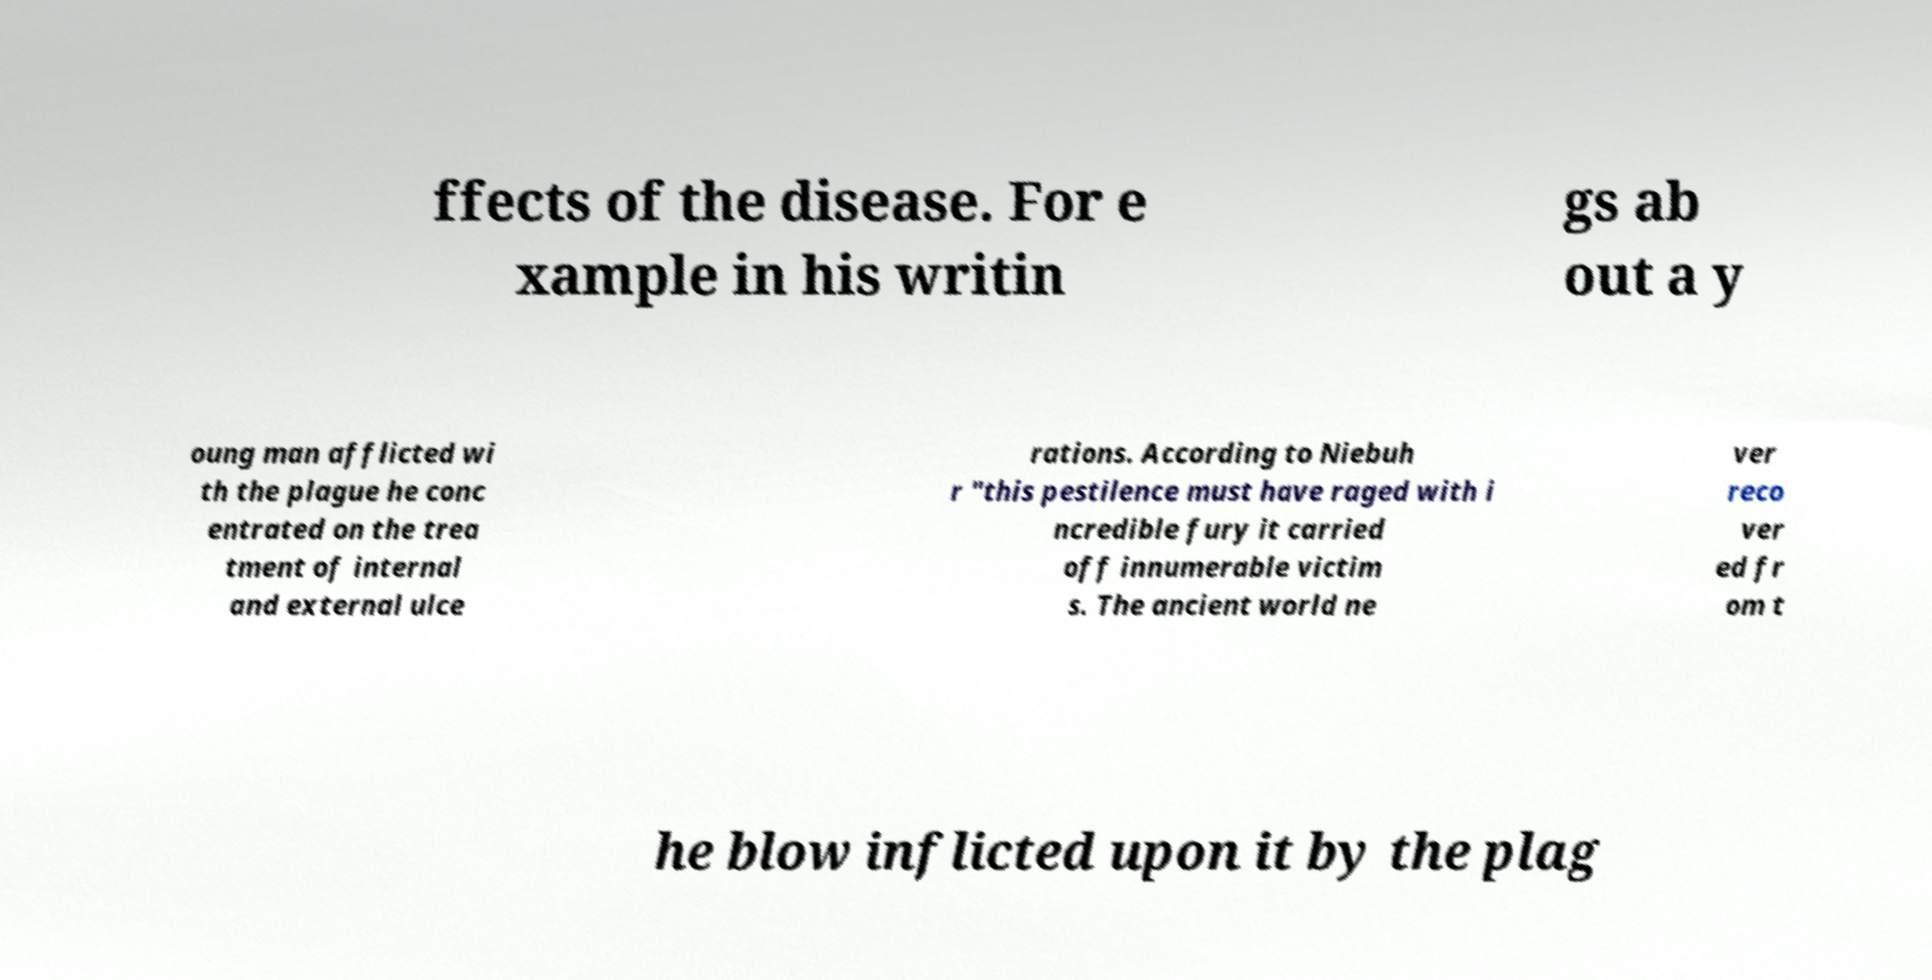Please read and relay the text visible in this image. What does it say? ffects of the disease. For e xample in his writin gs ab out a y oung man afflicted wi th the plague he conc entrated on the trea tment of internal and external ulce rations. According to Niebuh r "this pestilence must have raged with i ncredible fury it carried off innumerable victim s. The ancient world ne ver reco ver ed fr om t he blow inflicted upon it by the plag 